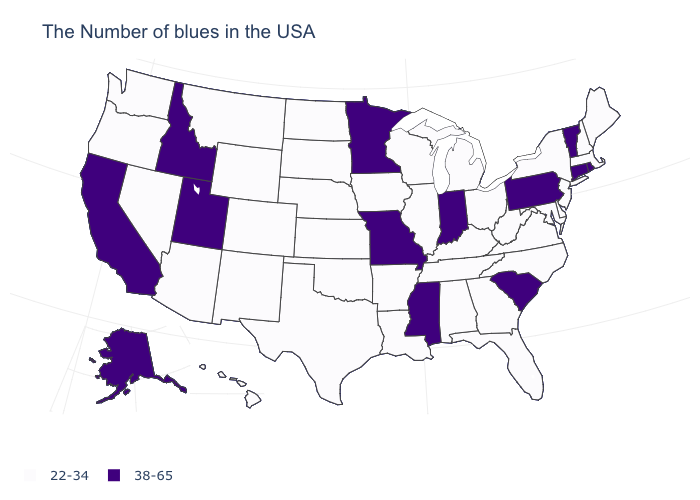Does Hawaii have a lower value than Idaho?
Concise answer only. Yes. What is the value of Rhode Island?
Write a very short answer. 38-65. Does the first symbol in the legend represent the smallest category?
Keep it brief. Yes. What is the highest value in the West ?
Give a very brief answer. 38-65. Which states have the lowest value in the Northeast?
Be succinct. Maine, Massachusetts, New Hampshire, New York, New Jersey. Name the states that have a value in the range 22-34?
Keep it brief. Maine, Massachusetts, New Hampshire, New York, New Jersey, Delaware, Maryland, Virginia, North Carolina, West Virginia, Ohio, Florida, Georgia, Michigan, Kentucky, Alabama, Tennessee, Wisconsin, Illinois, Louisiana, Arkansas, Iowa, Kansas, Nebraska, Oklahoma, Texas, South Dakota, North Dakota, Wyoming, Colorado, New Mexico, Montana, Arizona, Nevada, Washington, Oregon, Hawaii. What is the value of Indiana?
Write a very short answer. 38-65. What is the value of Hawaii?
Answer briefly. 22-34. Name the states that have a value in the range 22-34?
Write a very short answer. Maine, Massachusetts, New Hampshire, New York, New Jersey, Delaware, Maryland, Virginia, North Carolina, West Virginia, Ohio, Florida, Georgia, Michigan, Kentucky, Alabama, Tennessee, Wisconsin, Illinois, Louisiana, Arkansas, Iowa, Kansas, Nebraska, Oklahoma, Texas, South Dakota, North Dakota, Wyoming, Colorado, New Mexico, Montana, Arizona, Nevada, Washington, Oregon, Hawaii. Does West Virginia have the highest value in the South?
Give a very brief answer. No. Name the states that have a value in the range 38-65?
Quick response, please. Rhode Island, Vermont, Connecticut, Pennsylvania, South Carolina, Indiana, Mississippi, Missouri, Minnesota, Utah, Idaho, California, Alaska. Name the states that have a value in the range 22-34?
Concise answer only. Maine, Massachusetts, New Hampshire, New York, New Jersey, Delaware, Maryland, Virginia, North Carolina, West Virginia, Ohio, Florida, Georgia, Michigan, Kentucky, Alabama, Tennessee, Wisconsin, Illinois, Louisiana, Arkansas, Iowa, Kansas, Nebraska, Oklahoma, Texas, South Dakota, North Dakota, Wyoming, Colorado, New Mexico, Montana, Arizona, Nevada, Washington, Oregon, Hawaii. Name the states that have a value in the range 38-65?
Give a very brief answer. Rhode Island, Vermont, Connecticut, Pennsylvania, South Carolina, Indiana, Mississippi, Missouri, Minnesota, Utah, Idaho, California, Alaska. Name the states that have a value in the range 38-65?
Give a very brief answer. Rhode Island, Vermont, Connecticut, Pennsylvania, South Carolina, Indiana, Mississippi, Missouri, Minnesota, Utah, Idaho, California, Alaska. What is the value of Utah?
Write a very short answer. 38-65. 